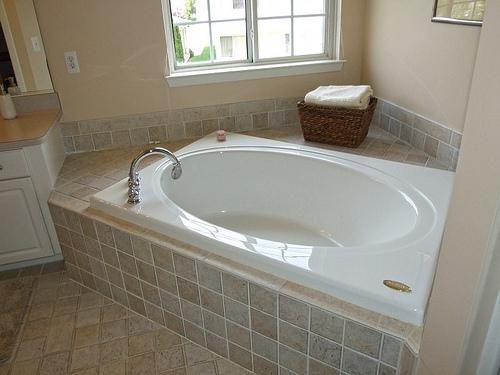Question: what material is covering the floor?
Choices:
A. Linoleum.
B. Tile.
C. Carpet.
D. Lucite.
Answer with the letter. Answer: B Question: how many baskets are visible?
Choices:
A. 2.
B. 3.
C. 5.
D. 1.
Answer with the letter. Answer: D Question: what color is the faucet?
Choices:
A. Silver.
B. Brown.
C. Gold.
D. Black.
Answer with the letter. Answer: A 